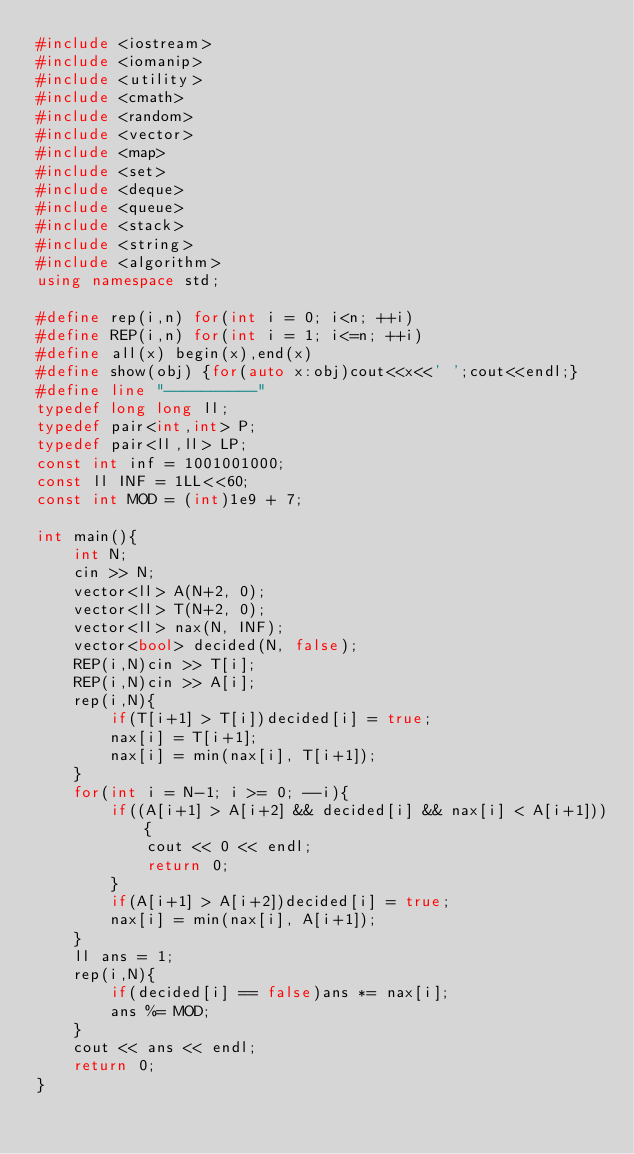<code> <loc_0><loc_0><loc_500><loc_500><_C++_>#include <iostream>
#include <iomanip>
#include <utility>
#include <cmath>
#include <random>
#include <vector>
#include <map>
#include <set>
#include <deque>
#include <queue>
#include <stack>
#include <string>
#include <algorithm>
using namespace std;

#define rep(i,n) for(int i = 0; i<n; ++i)
#define REP(i,n) for(int i = 1; i<=n; ++i)
#define all(x) begin(x),end(x)
#define show(obj) {for(auto x:obj)cout<<x<<' ';cout<<endl;}
#define line "----------"
typedef long long ll;
typedef pair<int,int> P;
typedef pair<ll,ll> LP;
const int inf = 1001001000;
const ll INF = 1LL<<60;
const int MOD = (int)1e9 + 7;

int main(){
	int N;
	cin >> N;
	vector<ll> A(N+2, 0);
	vector<ll> T(N+2, 0);
	vector<ll> nax(N, INF);
	vector<bool> decided(N, false);
	REP(i,N)cin >> T[i];
	REP(i,N)cin >> A[i];
	rep(i,N){
		if(T[i+1] > T[i])decided[i] = true;
		nax[i] = T[i+1];
		nax[i] = min(nax[i], T[i+1]);
	}
	for(int i = N-1; i >= 0; --i){
		if((A[i+1] > A[i+2] && decided[i] && nax[i] < A[i+1])){
			cout << 0 << endl;
			return 0;
		}
		if(A[i+1] > A[i+2])decided[i] = true;
		nax[i] = min(nax[i], A[i+1]);
	}
	ll ans = 1;
	rep(i,N){
		if(decided[i] == false)ans *= nax[i];
		ans %= MOD;
	}
	cout << ans << endl;
	return 0;
}
</code> 